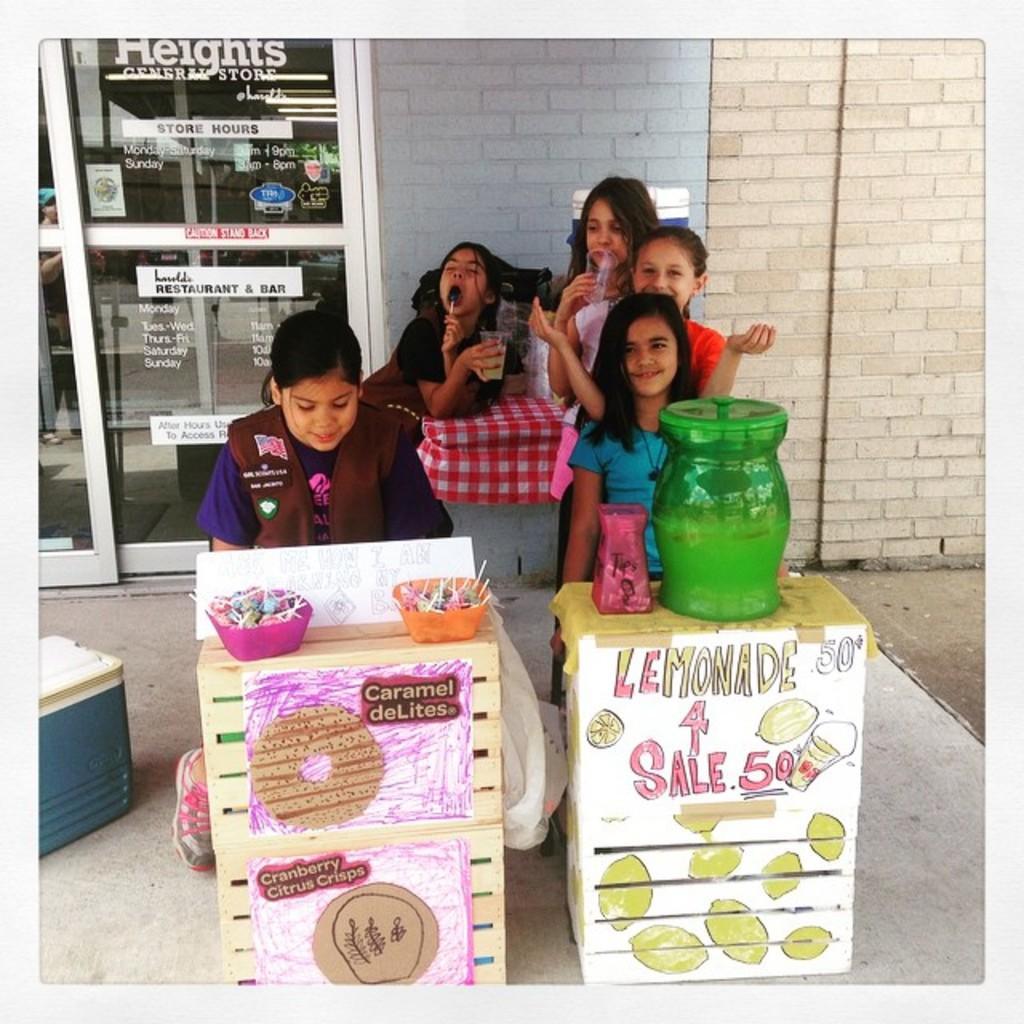Describe this image in one or two sentences. In this image, there are a few people. We can see some tables with objects and posters. We can see the ground with some objects. In the background, we can see the wall and some glass with text and the reflection. 